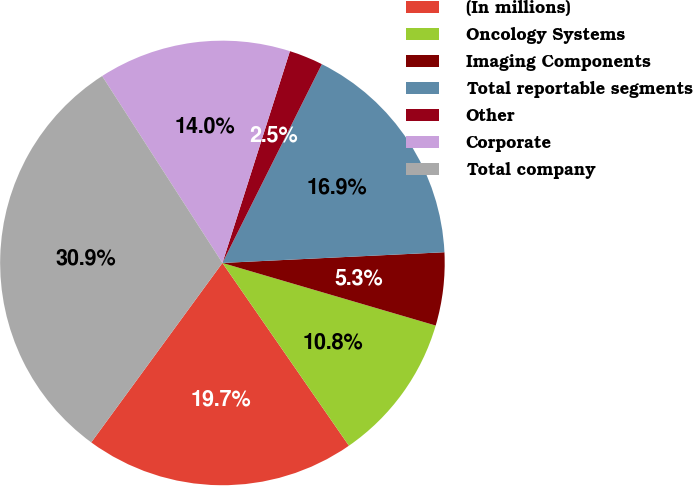Convert chart to OTSL. <chart><loc_0><loc_0><loc_500><loc_500><pie_chart><fcel>(In millions)<fcel>Oncology Systems<fcel>Imaging Components<fcel>Total reportable segments<fcel>Other<fcel>Corporate<fcel>Total company<nl><fcel>19.68%<fcel>10.82%<fcel>5.31%<fcel>16.85%<fcel>2.47%<fcel>14.01%<fcel>30.85%<nl></chart> 